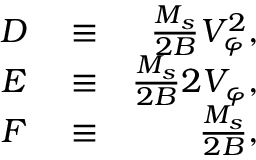<formula> <loc_0><loc_0><loc_500><loc_500>\begin{array} { r l r } { D } & \equiv } & { \frac { M _ { s } } { 2 B } V _ { \varphi } ^ { 2 } , } \\ { E } & \equiv } & { \frac { M _ { s } } { 2 B } 2 V _ { \varphi } , } \\ { F } & \equiv } & { \frac { M _ { s } } { 2 B } , } \end{array}</formula> 